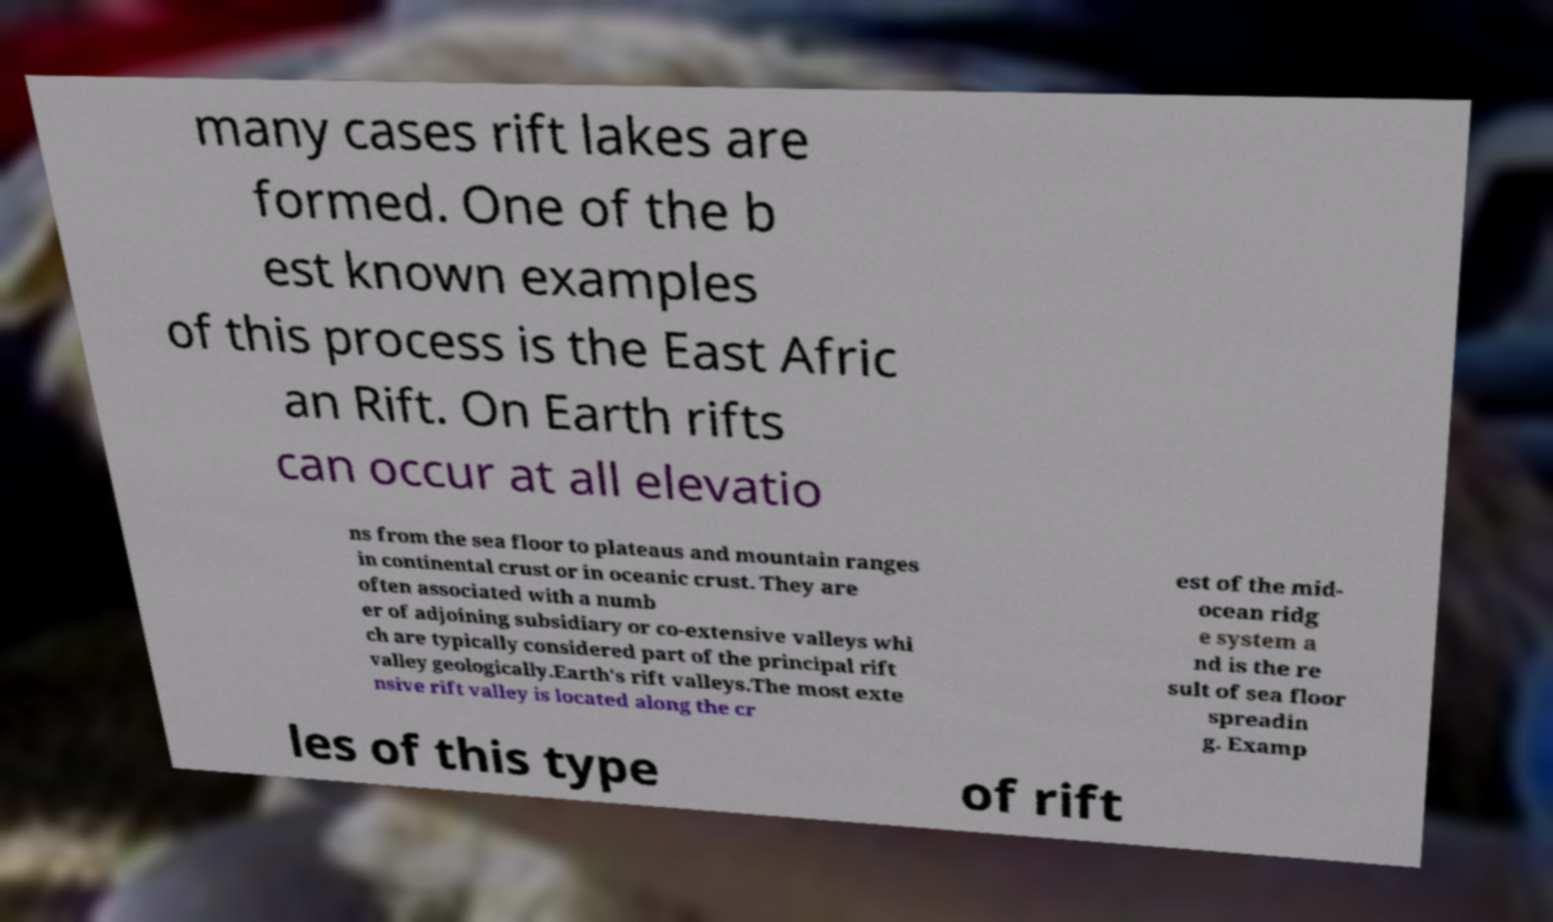For documentation purposes, I need the text within this image transcribed. Could you provide that? many cases rift lakes are formed. One of the b est known examples of this process is the East Afric an Rift. On Earth rifts can occur at all elevatio ns from the sea floor to plateaus and mountain ranges in continental crust or in oceanic crust. They are often associated with a numb er of adjoining subsidiary or co-extensive valleys whi ch are typically considered part of the principal rift valley geologically.Earth's rift valleys.The most exte nsive rift valley is located along the cr est of the mid- ocean ridg e system a nd is the re sult of sea floor spreadin g. Examp les of this type of rift 